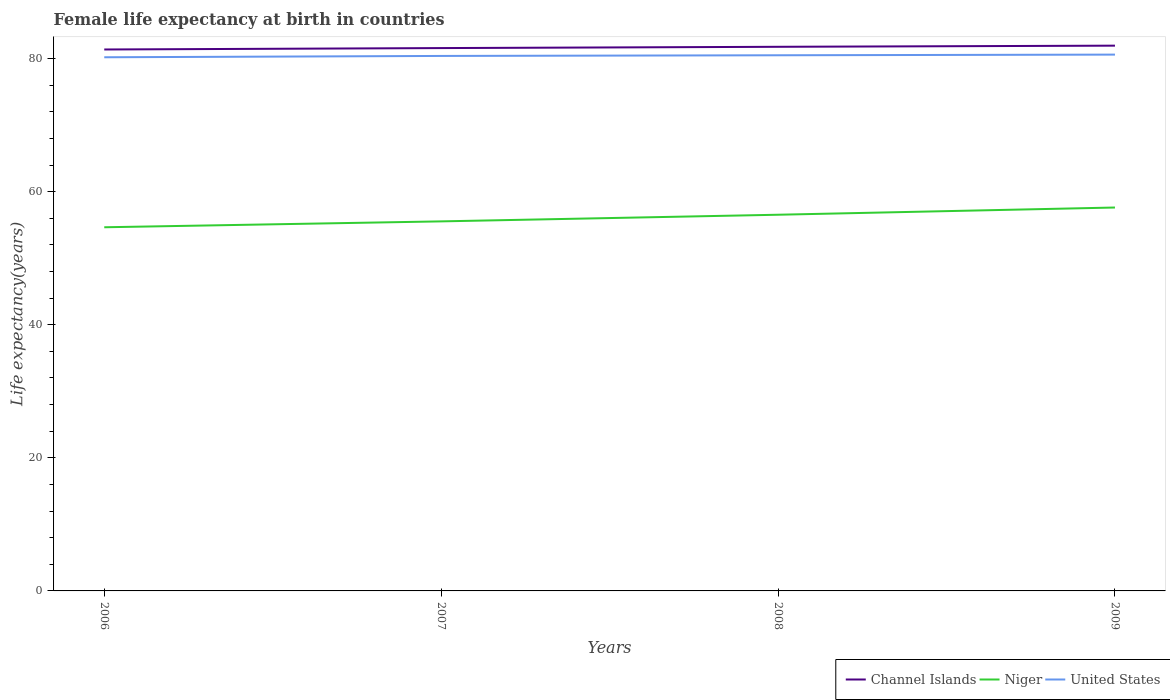Does the line corresponding to Niger intersect with the line corresponding to Channel Islands?
Give a very brief answer. No. Is the number of lines equal to the number of legend labels?
Make the answer very short. Yes. Across all years, what is the maximum female life expectancy at birth in Channel Islands?
Ensure brevity in your answer.  81.37. What is the total female life expectancy at birth in Channel Islands in the graph?
Your answer should be very brief. -0.36. What is the difference between the highest and the second highest female life expectancy at birth in Niger?
Offer a terse response. 2.97. What is the difference between the highest and the lowest female life expectancy at birth in Channel Islands?
Offer a terse response. 2. How many years are there in the graph?
Provide a short and direct response. 4. What is the difference between two consecutive major ticks on the Y-axis?
Provide a succinct answer. 20. How many legend labels are there?
Your answer should be very brief. 3. What is the title of the graph?
Offer a very short reply. Female life expectancy at birth in countries. What is the label or title of the X-axis?
Ensure brevity in your answer.  Years. What is the label or title of the Y-axis?
Offer a terse response. Life expectancy(years). What is the Life expectancy(years) of Channel Islands in 2006?
Offer a very short reply. 81.37. What is the Life expectancy(years) of Niger in 2006?
Keep it short and to the point. 54.65. What is the Life expectancy(years) of United States in 2006?
Your answer should be compact. 80.2. What is the Life expectancy(years) in Channel Islands in 2007?
Provide a short and direct response. 81.58. What is the Life expectancy(years) in Niger in 2007?
Offer a very short reply. 55.54. What is the Life expectancy(years) in United States in 2007?
Provide a succinct answer. 80.4. What is the Life expectancy(years) of Channel Islands in 2008?
Offer a terse response. 81.77. What is the Life expectancy(years) of Niger in 2008?
Offer a very short reply. 56.53. What is the Life expectancy(years) in United States in 2008?
Give a very brief answer. 80.5. What is the Life expectancy(years) of Channel Islands in 2009?
Your response must be concise. 81.94. What is the Life expectancy(years) of Niger in 2009?
Ensure brevity in your answer.  57.62. What is the Life expectancy(years) of United States in 2009?
Offer a terse response. 80.6. Across all years, what is the maximum Life expectancy(years) of Channel Islands?
Your answer should be compact. 81.94. Across all years, what is the maximum Life expectancy(years) in Niger?
Provide a short and direct response. 57.62. Across all years, what is the maximum Life expectancy(years) of United States?
Provide a short and direct response. 80.6. Across all years, what is the minimum Life expectancy(years) in Channel Islands?
Make the answer very short. 81.37. Across all years, what is the minimum Life expectancy(years) in Niger?
Offer a very short reply. 54.65. Across all years, what is the minimum Life expectancy(years) in United States?
Your answer should be compact. 80.2. What is the total Life expectancy(years) of Channel Islands in the graph?
Your answer should be very brief. 326.67. What is the total Life expectancy(years) of Niger in the graph?
Provide a succinct answer. 224.34. What is the total Life expectancy(years) in United States in the graph?
Your answer should be compact. 321.7. What is the difference between the Life expectancy(years) in Channel Islands in 2006 and that in 2007?
Your response must be concise. -0.21. What is the difference between the Life expectancy(years) of Niger in 2006 and that in 2007?
Provide a succinct answer. -0.89. What is the difference between the Life expectancy(years) of United States in 2006 and that in 2007?
Make the answer very short. -0.2. What is the difference between the Life expectancy(years) in Channel Islands in 2006 and that in 2008?
Your answer should be compact. -0.4. What is the difference between the Life expectancy(years) in Niger in 2006 and that in 2008?
Keep it short and to the point. -1.88. What is the difference between the Life expectancy(years) of United States in 2006 and that in 2008?
Offer a very short reply. -0.3. What is the difference between the Life expectancy(years) in Channel Islands in 2006 and that in 2009?
Ensure brevity in your answer.  -0.57. What is the difference between the Life expectancy(years) of Niger in 2006 and that in 2009?
Give a very brief answer. -2.97. What is the difference between the Life expectancy(years) of United States in 2006 and that in 2009?
Your response must be concise. -0.4. What is the difference between the Life expectancy(years) in Channel Islands in 2007 and that in 2008?
Provide a succinct answer. -0.19. What is the difference between the Life expectancy(years) of Niger in 2007 and that in 2008?
Offer a very short reply. -1. What is the difference between the Life expectancy(years) in Channel Islands in 2007 and that in 2009?
Offer a very short reply. -0.36. What is the difference between the Life expectancy(years) of Niger in 2007 and that in 2009?
Your answer should be very brief. -2.08. What is the difference between the Life expectancy(years) in Channel Islands in 2008 and that in 2009?
Provide a succinct answer. -0.17. What is the difference between the Life expectancy(years) of Niger in 2008 and that in 2009?
Offer a terse response. -1.08. What is the difference between the Life expectancy(years) in Channel Islands in 2006 and the Life expectancy(years) in Niger in 2007?
Your answer should be compact. 25.83. What is the difference between the Life expectancy(years) of Niger in 2006 and the Life expectancy(years) of United States in 2007?
Offer a very short reply. -25.75. What is the difference between the Life expectancy(years) of Channel Islands in 2006 and the Life expectancy(years) of Niger in 2008?
Make the answer very short. 24.84. What is the difference between the Life expectancy(years) in Channel Islands in 2006 and the Life expectancy(years) in United States in 2008?
Provide a succinct answer. 0.87. What is the difference between the Life expectancy(years) of Niger in 2006 and the Life expectancy(years) of United States in 2008?
Ensure brevity in your answer.  -25.85. What is the difference between the Life expectancy(years) of Channel Islands in 2006 and the Life expectancy(years) of Niger in 2009?
Your answer should be very brief. 23.75. What is the difference between the Life expectancy(years) in Channel Islands in 2006 and the Life expectancy(years) in United States in 2009?
Your answer should be compact. 0.77. What is the difference between the Life expectancy(years) in Niger in 2006 and the Life expectancy(years) in United States in 2009?
Your response must be concise. -25.95. What is the difference between the Life expectancy(years) of Channel Islands in 2007 and the Life expectancy(years) of Niger in 2008?
Ensure brevity in your answer.  25.05. What is the difference between the Life expectancy(years) of Channel Islands in 2007 and the Life expectancy(years) of United States in 2008?
Keep it short and to the point. 1.08. What is the difference between the Life expectancy(years) of Niger in 2007 and the Life expectancy(years) of United States in 2008?
Your answer should be very brief. -24.96. What is the difference between the Life expectancy(years) in Channel Islands in 2007 and the Life expectancy(years) in Niger in 2009?
Offer a terse response. 23.96. What is the difference between the Life expectancy(years) in Channel Islands in 2007 and the Life expectancy(years) in United States in 2009?
Offer a very short reply. 0.98. What is the difference between the Life expectancy(years) in Niger in 2007 and the Life expectancy(years) in United States in 2009?
Make the answer very short. -25.06. What is the difference between the Life expectancy(years) of Channel Islands in 2008 and the Life expectancy(years) of Niger in 2009?
Provide a succinct answer. 24.15. What is the difference between the Life expectancy(years) in Channel Islands in 2008 and the Life expectancy(years) in United States in 2009?
Make the answer very short. 1.17. What is the difference between the Life expectancy(years) of Niger in 2008 and the Life expectancy(years) of United States in 2009?
Your answer should be compact. -24.07. What is the average Life expectancy(years) of Channel Islands per year?
Your answer should be very brief. 81.67. What is the average Life expectancy(years) in Niger per year?
Provide a short and direct response. 56.09. What is the average Life expectancy(years) of United States per year?
Provide a short and direct response. 80.42. In the year 2006, what is the difference between the Life expectancy(years) in Channel Islands and Life expectancy(years) in Niger?
Make the answer very short. 26.72. In the year 2006, what is the difference between the Life expectancy(years) in Channel Islands and Life expectancy(years) in United States?
Keep it short and to the point. 1.17. In the year 2006, what is the difference between the Life expectancy(years) in Niger and Life expectancy(years) in United States?
Your answer should be compact. -25.55. In the year 2007, what is the difference between the Life expectancy(years) in Channel Islands and Life expectancy(years) in Niger?
Provide a succinct answer. 26.04. In the year 2007, what is the difference between the Life expectancy(years) in Channel Islands and Life expectancy(years) in United States?
Your answer should be compact. 1.18. In the year 2007, what is the difference between the Life expectancy(years) of Niger and Life expectancy(years) of United States?
Provide a succinct answer. -24.86. In the year 2008, what is the difference between the Life expectancy(years) in Channel Islands and Life expectancy(years) in Niger?
Ensure brevity in your answer.  25.24. In the year 2008, what is the difference between the Life expectancy(years) in Channel Islands and Life expectancy(years) in United States?
Offer a terse response. 1.27. In the year 2008, what is the difference between the Life expectancy(years) of Niger and Life expectancy(years) of United States?
Your answer should be compact. -23.96. In the year 2009, what is the difference between the Life expectancy(years) in Channel Islands and Life expectancy(years) in Niger?
Your response must be concise. 24.32. In the year 2009, what is the difference between the Life expectancy(years) of Channel Islands and Life expectancy(years) of United States?
Keep it short and to the point. 1.34. In the year 2009, what is the difference between the Life expectancy(years) in Niger and Life expectancy(years) in United States?
Make the answer very short. -22.98. What is the ratio of the Life expectancy(years) in Niger in 2006 to that in 2007?
Give a very brief answer. 0.98. What is the ratio of the Life expectancy(years) of Channel Islands in 2006 to that in 2008?
Your answer should be very brief. 1. What is the ratio of the Life expectancy(years) of Niger in 2006 to that in 2008?
Your response must be concise. 0.97. What is the ratio of the Life expectancy(years) of United States in 2006 to that in 2008?
Offer a very short reply. 1. What is the ratio of the Life expectancy(years) of Channel Islands in 2006 to that in 2009?
Give a very brief answer. 0.99. What is the ratio of the Life expectancy(years) in Niger in 2006 to that in 2009?
Offer a very short reply. 0.95. What is the ratio of the Life expectancy(years) in Niger in 2007 to that in 2008?
Give a very brief answer. 0.98. What is the ratio of the Life expectancy(years) in Channel Islands in 2007 to that in 2009?
Your response must be concise. 1. What is the ratio of the Life expectancy(years) in Niger in 2007 to that in 2009?
Provide a short and direct response. 0.96. What is the ratio of the Life expectancy(years) in United States in 2007 to that in 2009?
Make the answer very short. 1. What is the ratio of the Life expectancy(years) of Channel Islands in 2008 to that in 2009?
Keep it short and to the point. 1. What is the ratio of the Life expectancy(years) in Niger in 2008 to that in 2009?
Make the answer very short. 0.98. What is the difference between the highest and the second highest Life expectancy(years) of Channel Islands?
Provide a succinct answer. 0.17. What is the difference between the highest and the second highest Life expectancy(years) in Niger?
Your answer should be very brief. 1.08. What is the difference between the highest and the second highest Life expectancy(years) in United States?
Provide a short and direct response. 0.1. What is the difference between the highest and the lowest Life expectancy(years) of Channel Islands?
Ensure brevity in your answer.  0.57. What is the difference between the highest and the lowest Life expectancy(years) in Niger?
Keep it short and to the point. 2.97. What is the difference between the highest and the lowest Life expectancy(years) in United States?
Your answer should be very brief. 0.4. 